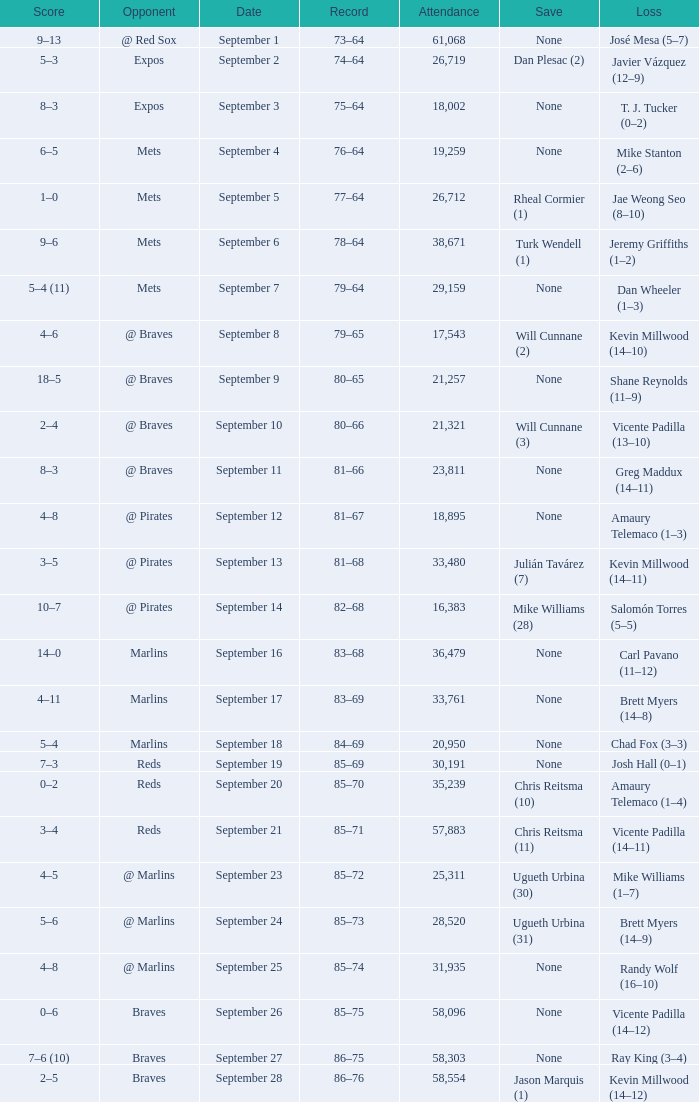What was the score of the game that had a loss of Chad Fox (3–3)? 5–4. 